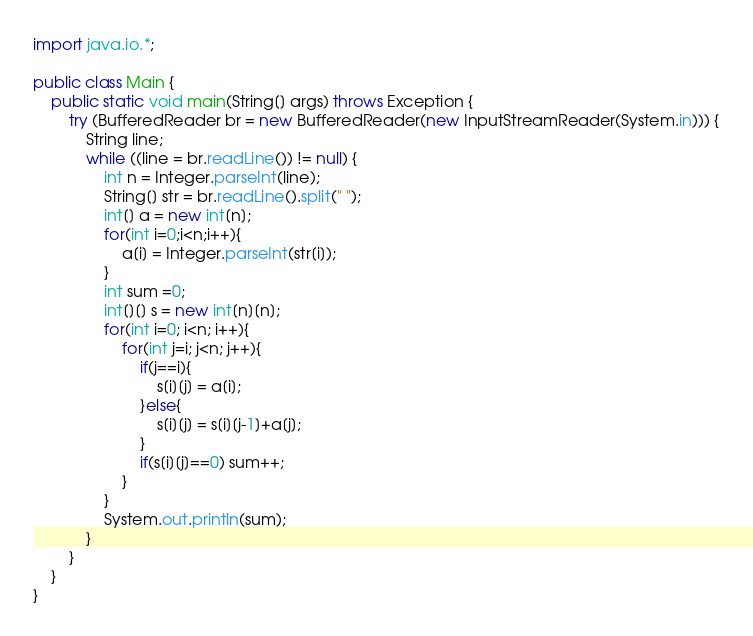<code> <loc_0><loc_0><loc_500><loc_500><_Java_>import java.io.*;

public class Main {
    public static void main(String[] args) throws Exception {
        try (BufferedReader br = new BufferedReader(new InputStreamReader(System.in))) {
            String line;
            while ((line = br.readLine()) != null) {
                int n = Integer.parseInt(line);
                String[] str = br.readLine().split(" ");
                int[] a = new int[n];
                for(int i=0;i<n;i++){
                    a[i] = Integer.parseInt(str[i]);
                }
                int sum =0;
                int[][] s = new int[n][n];
                for(int i=0; i<n; i++){
                    for(int j=i; j<n; j++){
                        if(j==i){
                            s[i][j] = a[i];
                        }else{
                            s[i][j] = s[i][j-1]+a[j];
                        }
                        if(s[i][j]==0) sum++;
                    }
                }
                System.out.println(sum);
            }
        }
    }
}</code> 